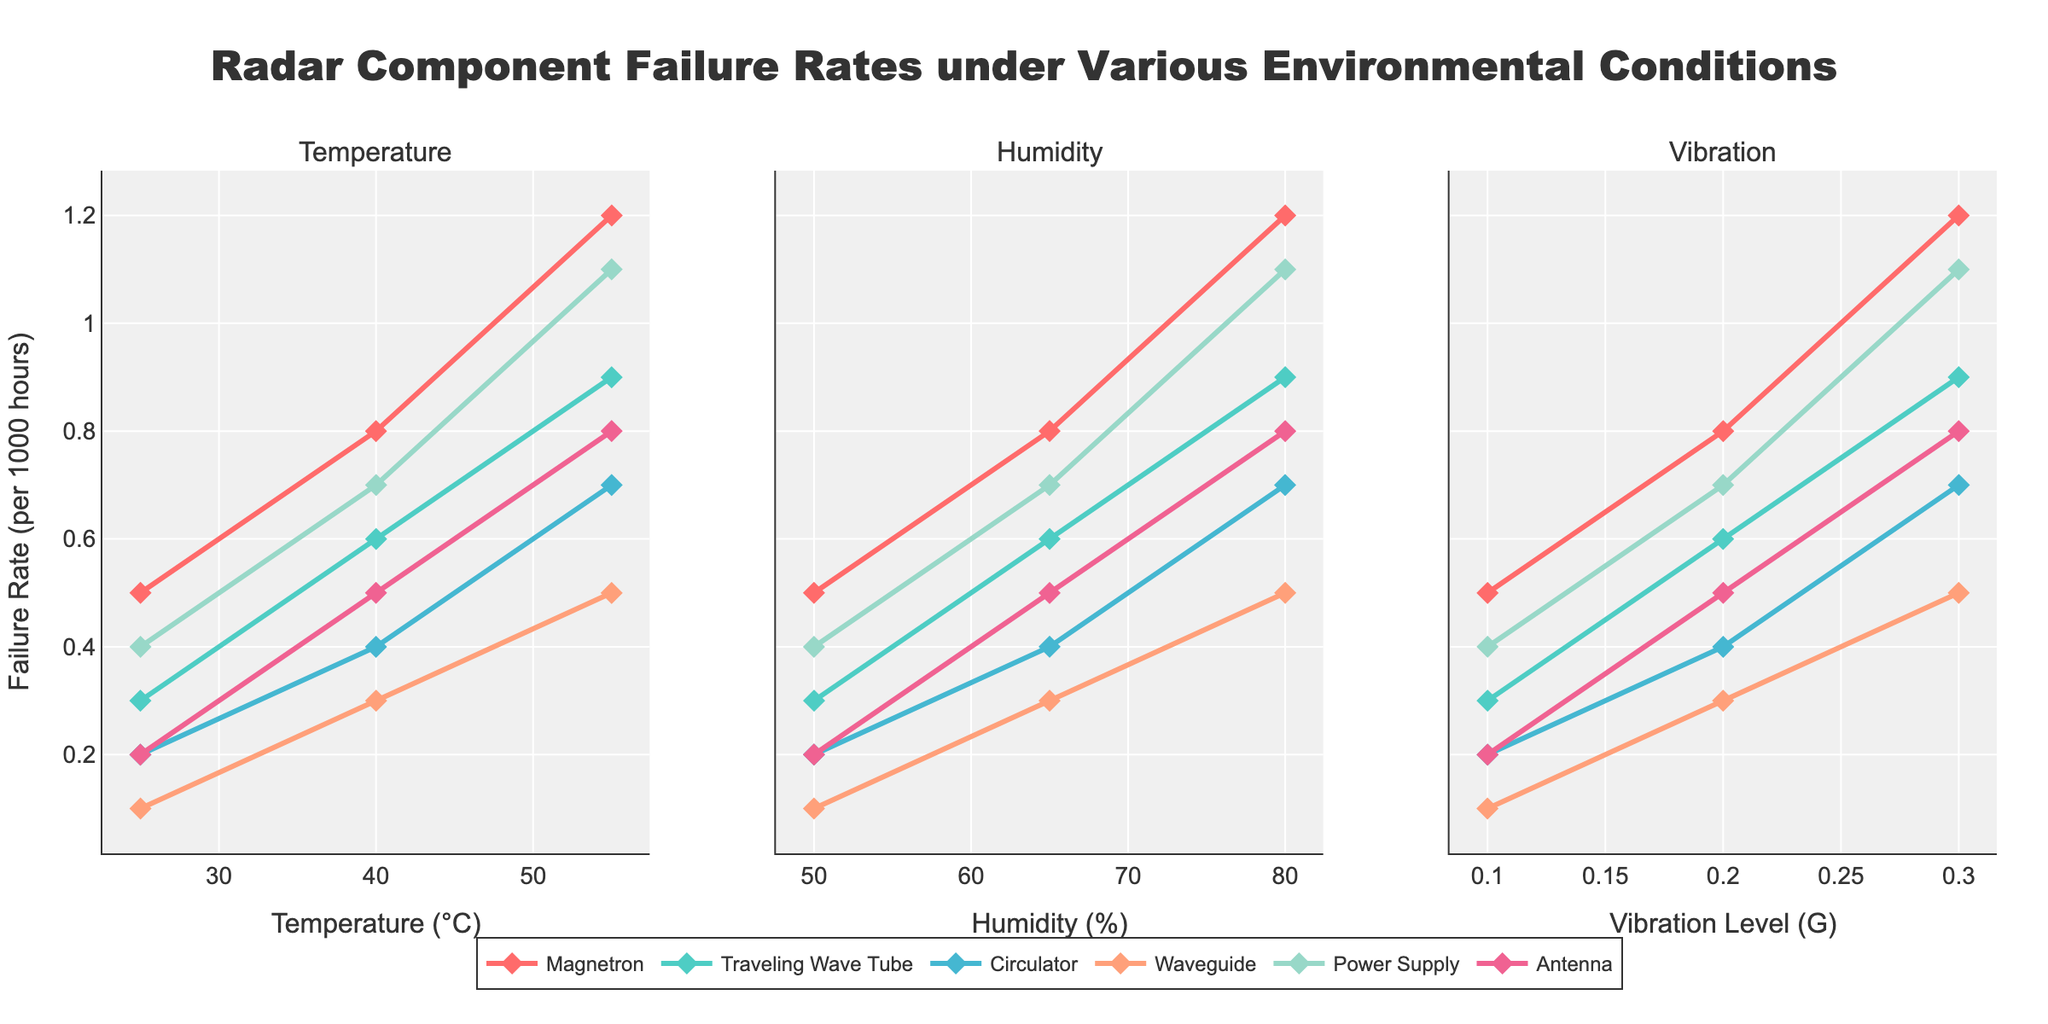What is the failure rate of the Magnetron at 55°C? Look at the "Temperature" subplot and identify the failure rate for the Magnetron when the temperature is 55°C. The data point shows a failure rate of 1.2.
Answer: 1.2 Which component has the lowest failure rate at 25°C? Check the "Temperature" subplot and locate all components at 25°C. The Waveguide has the lowest failure rate of 0.1.
Answer: Waveguide What is the difference in failure rate between the Magnetron and Power Supply at 40°C? Find the failure rates of the Magnetron and Power Supply at 40°C in the "Temperature" subplot. The failure rates are 0.8 for Magnetron and 0.7 for Power Supply. The difference is 0.8 - 0.7.
Answer: 0.1 Which component shows the greatest increase in failure rate when humidity changes from 50% to 80%? Observe the "Humidity" subplot to see the change in failure rates from 50% to 80%. The Magnetron has the largest increase from 0.5 to 1.2, an increase of 0.7.
Answer: Magnetron How does the failure rate of the Traveling Wave Tube compare to the Circulator at a vibration level of 0.3G? Look at the "Vibration" subplot for the failure rates at 0.3G. The failure rate of the Traveling Wave Tube is 0.9, while the Circulator is 0.7. The Traveling Wave Tube has a higher failure rate.
Answer: Traveling Wave Tube What is the average failure rate of the Antenna across all measured temperatures? Find the failure rates of the Antenna at 25°C, 40°C, and 55°C in the "Temperature" subplot: 0.2, 0.5, and 0.8. Calculate the average: (0.2 + 0.5 + 0.8) / 3.
Answer: 0.5 Which component has the highest failure rate at 65% humidity? Refer to the "Humidity" subplot and locate the data points at 65% humidity. The highest failure rate is 0.8 for the Magnetron.
Answer: Magnetron How much does the failure rate for the Circulator increase from a vibration level of 0.1G to 0.3G? In the "Vibration" subplot, find the failure rates for the Circulator at 0.1G and 0.3G: 0.2 and 0.7 respectively. The increase is 0.7 - 0.2.
Answer: 0.5 What is the failure rate of the Power Supply under 50% humidity? Look at the "Humidity" subplot and find the failure rate for the Power Supply at 50% humidity. The failure rate is 0.4.
Answer: 0.4 Which environmental factor (temperature, humidity, vibration) shows the greatest variation in failure rates for the Magnetron? Compare the range of failure rates for the Magnetron across temperature, humidity, and vibration subplots. Temperature variation is highest, ranging from 0.5 to 1.2 (a variation of 0.7).
Answer: Temperature 